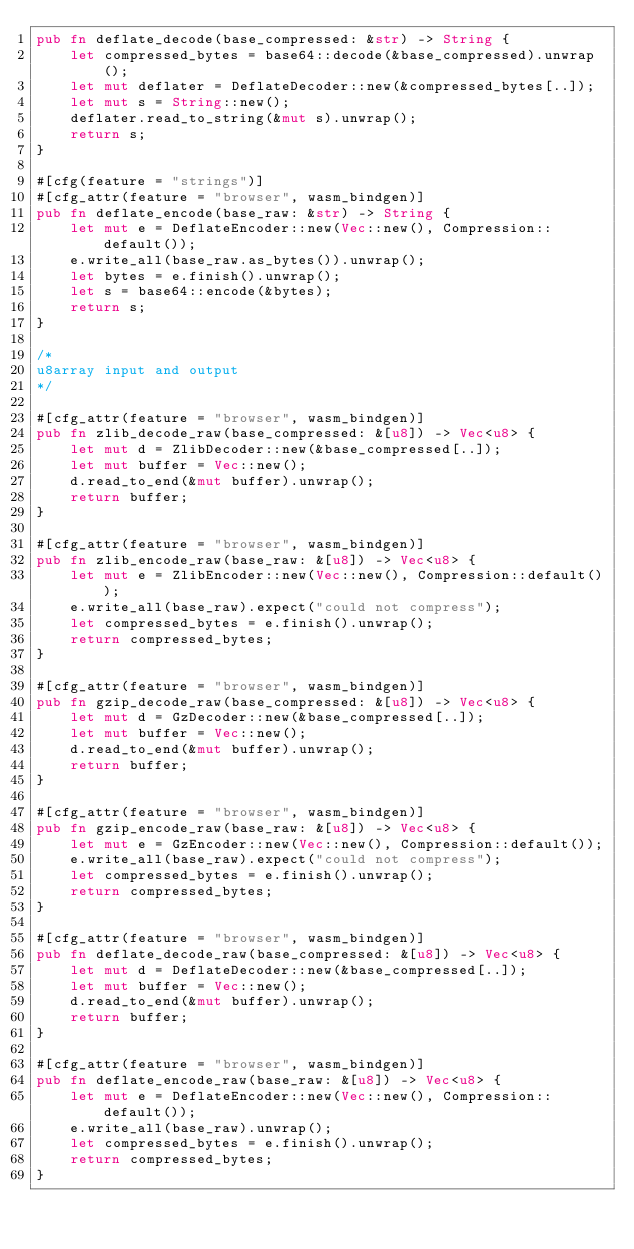Convert code to text. <code><loc_0><loc_0><loc_500><loc_500><_Rust_>pub fn deflate_decode(base_compressed: &str) -> String {
    let compressed_bytes = base64::decode(&base_compressed).unwrap();
    let mut deflater = DeflateDecoder::new(&compressed_bytes[..]);
    let mut s = String::new();
    deflater.read_to_string(&mut s).unwrap();
    return s;
}

#[cfg(feature = "strings")]
#[cfg_attr(feature = "browser", wasm_bindgen)]
pub fn deflate_encode(base_raw: &str) -> String {
    let mut e = DeflateEncoder::new(Vec::new(), Compression::default());
    e.write_all(base_raw.as_bytes()).unwrap();
    let bytes = e.finish().unwrap();
    let s = base64::encode(&bytes);
    return s;
}

/*
u8array input and output
*/

#[cfg_attr(feature = "browser", wasm_bindgen)]
pub fn zlib_decode_raw(base_compressed: &[u8]) -> Vec<u8> {
    let mut d = ZlibDecoder::new(&base_compressed[..]);
    let mut buffer = Vec::new();
    d.read_to_end(&mut buffer).unwrap();
    return buffer;
}

#[cfg_attr(feature = "browser", wasm_bindgen)]
pub fn zlib_encode_raw(base_raw: &[u8]) -> Vec<u8> {
    let mut e = ZlibEncoder::new(Vec::new(), Compression::default());
    e.write_all(base_raw).expect("could not compress");
    let compressed_bytes = e.finish().unwrap();
    return compressed_bytes;
}

#[cfg_attr(feature = "browser", wasm_bindgen)]
pub fn gzip_decode_raw(base_compressed: &[u8]) -> Vec<u8> {
    let mut d = GzDecoder::new(&base_compressed[..]);
    let mut buffer = Vec::new();
    d.read_to_end(&mut buffer).unwrap();
    return buffer;
}

#[cfg_attr(feature = "browser", wasm_bindgen)]
pub fn gzip_encode_raw(base_raw: &[u8]) -> Vec<u8> {
    let mut e = GzEncoder::new(Vec::new(), Compression::default());
    e.write_all(base_raw).expect("could not compress");
    let compressed_bytes = e.finish().unwrap();
    return compressed_bytes;
}

#[cfg_attr(feature = "browser", wasm_bindgen)]
pub fn deflate_decode_raw(base_compressed: &[u8]) -> Vec<u8> {
    let mut d = DeflateDecoder::new(&base_compressed[..]);
    let mut buffer = Vec::new();
    d.read_to_end(&mut buffer).unwrap();
    return buffer;
}

#[cfg_attr(feature = "browser", wasm_bindgen)]
pub fn deflate_encode_raw(base_raw: &[u8]) -> Vec<u8> {
    let mut e = DeflateEncoder::new(Vec::new(), Compression::default());
    e.write_all(base_raw).unwrap();
    let compressed_bytes = e.finish().unwrap();
    return compressed_bytes;
}
</code> 